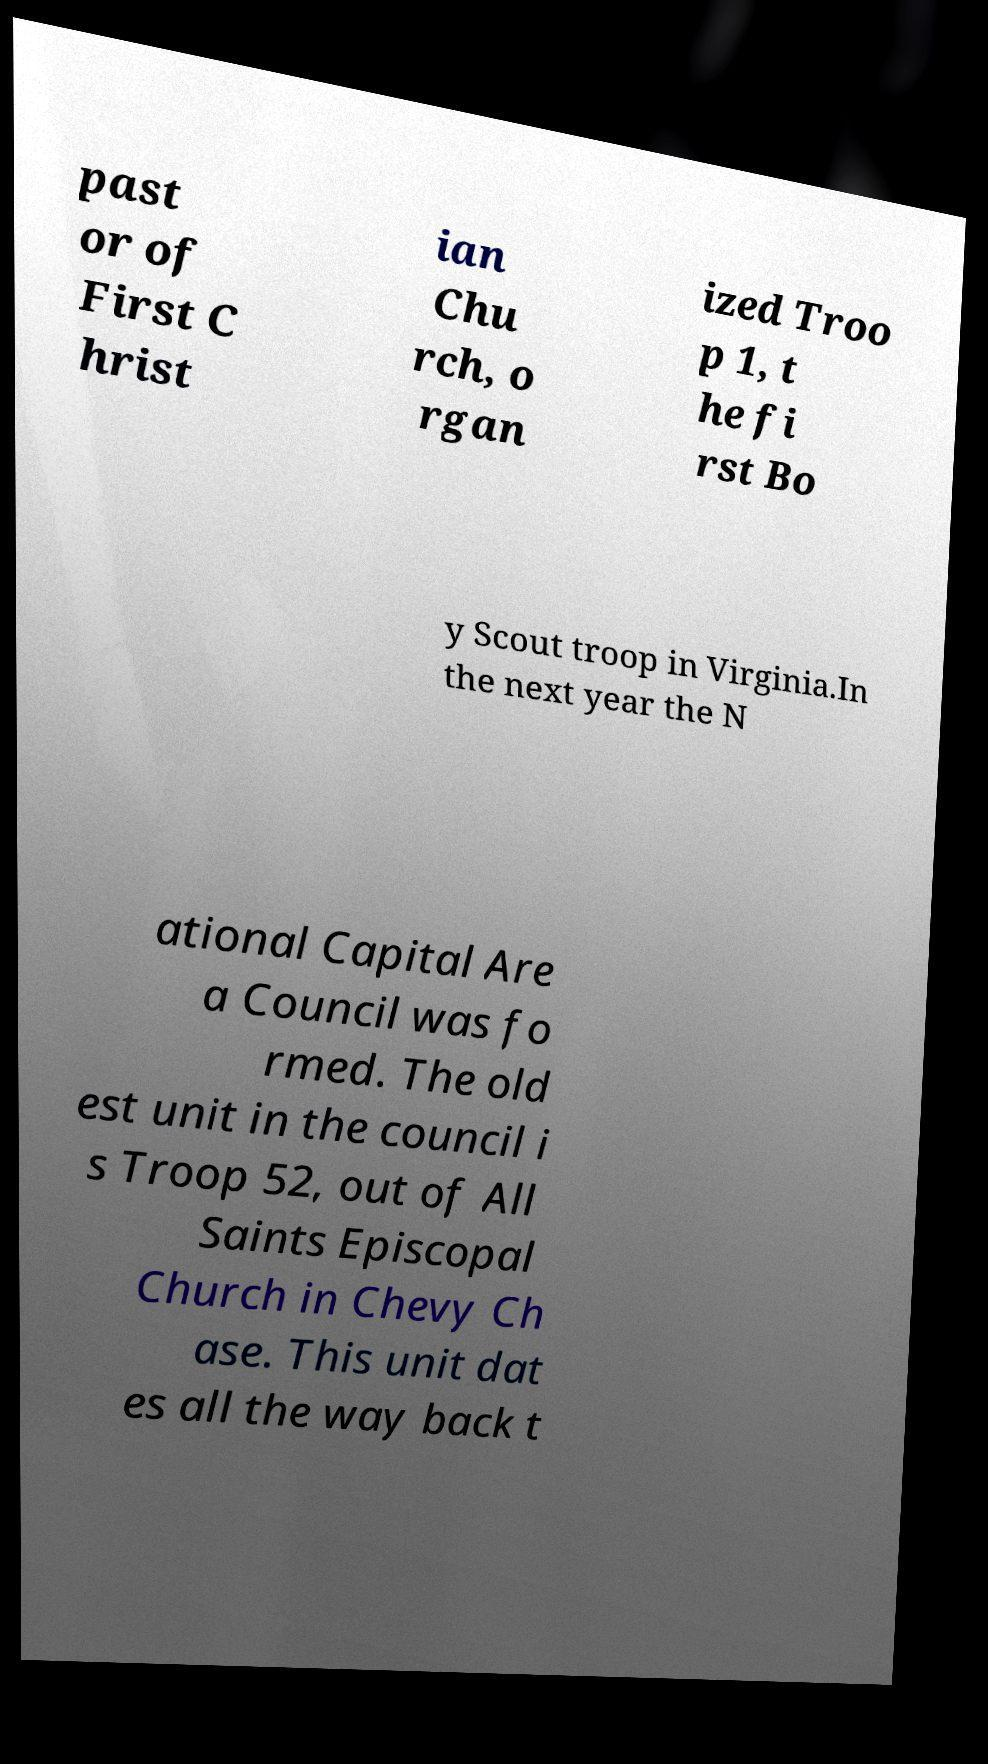Please identify and transcribe the text found in this image. past or of First C hrist ian Chu rch, o rgan ized Troo p 1, t he fi rst Bo y Scout troop in Virginia.In the next year the N ational Capital Are a Council was fo rmed. The old est unit in the council i s Troop 52, out of All Saints Episcopal Church in Chevy Ch ase. This unit dat es all the way back t 